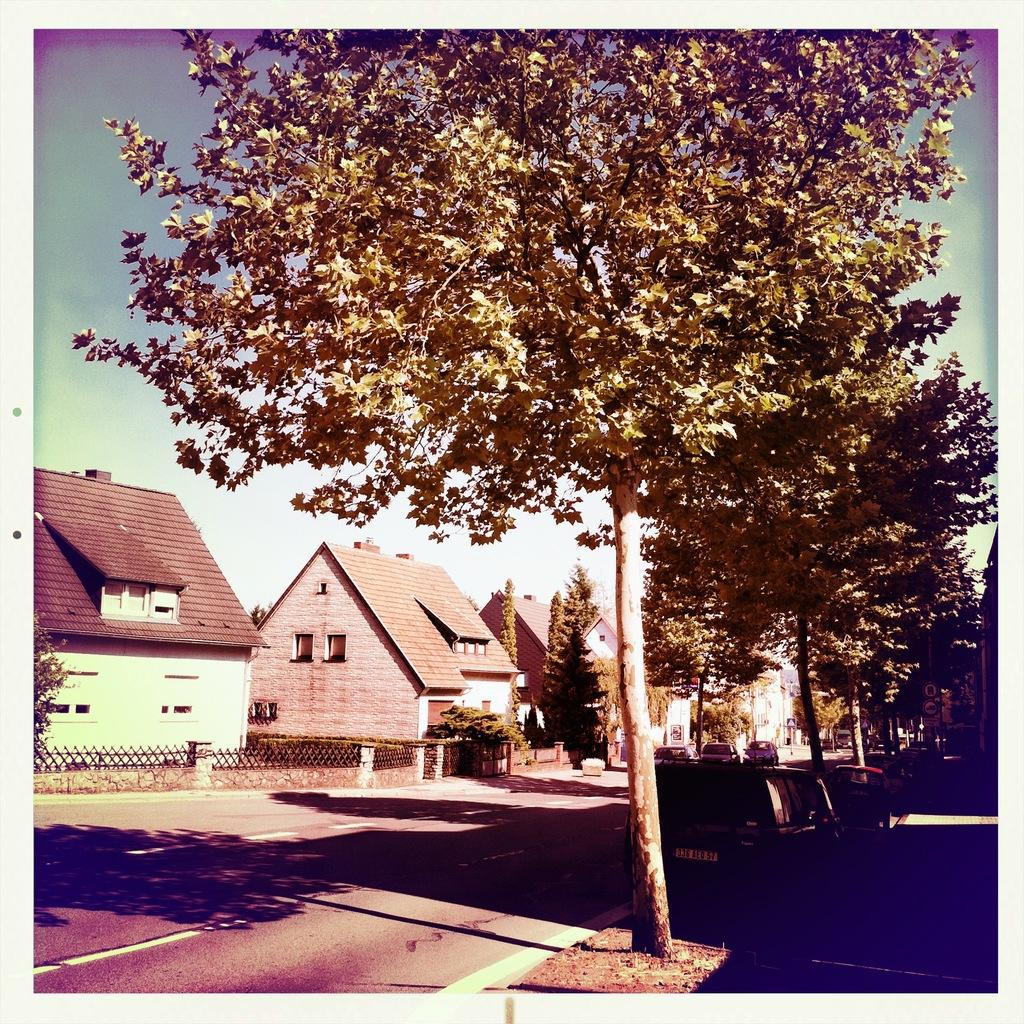What type of structures can be seen in the image? There are houses in the image. What other natural elements are present in the image? There are trees in the image. Are there any vehicles visible in the image? Yes, there are cars in the image. What can be seen in the sky in the image? The sky is visible in the image, and there are clouds present. What is the surface on which the cars are traveling in the image? There is a road in the image. What is the distribution of the theory of relativity in the image? There is no reference to the theory of relativity in the image, so it is not possible to determine its distribution. 